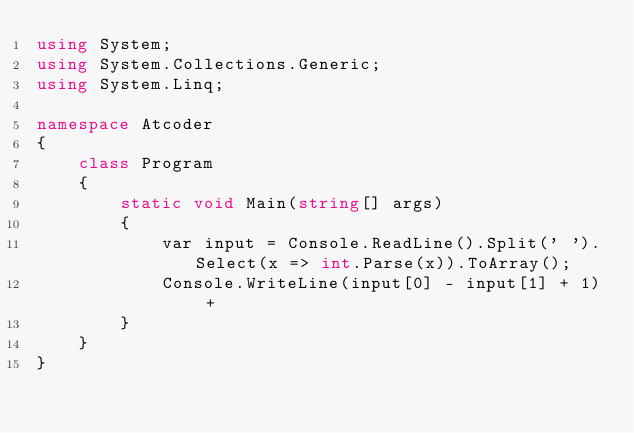<code> <loc_0><loc_0><loc_500><loc_500><_C#_>using System;
using System.Collections.Generic;
using System.Linq;

namespace Atcoder
{
    class Program
    {
        static void Main(string[] args)
        {
            var input = Console.ReadLine().Split(' ').Select(x => int.Parse(x)).ToArray();
            Console.WriteLine(input[0] - input[1] + 1) +
        }
    }
}</code> 